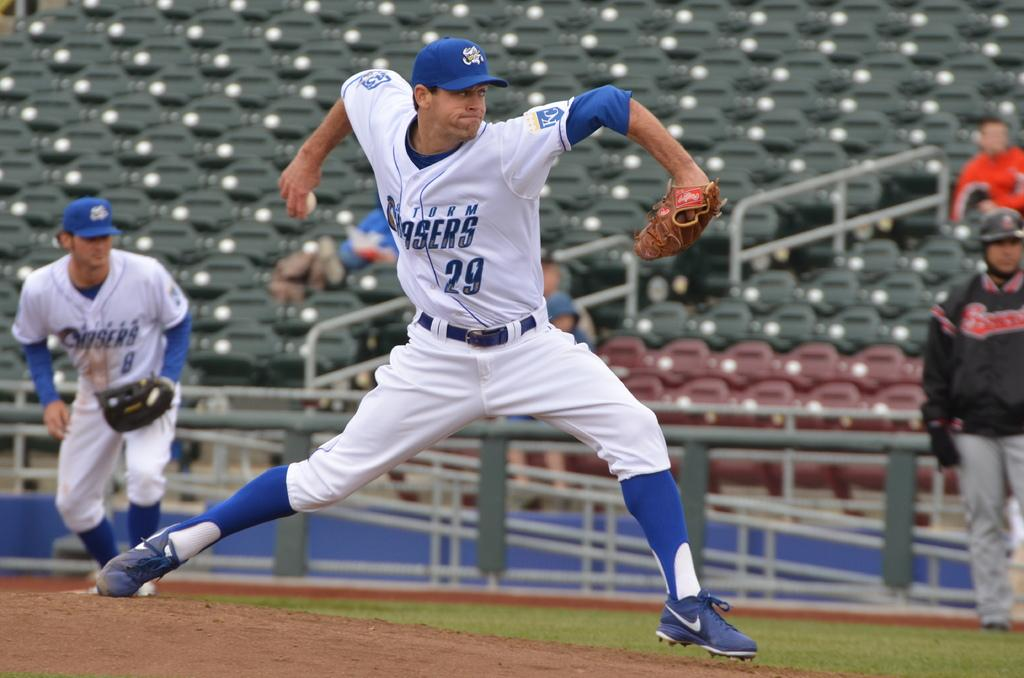<image>
Share a concise interpretation of the image provided. Number 29 of the Storm Chasers is about to pitch the baseball. 